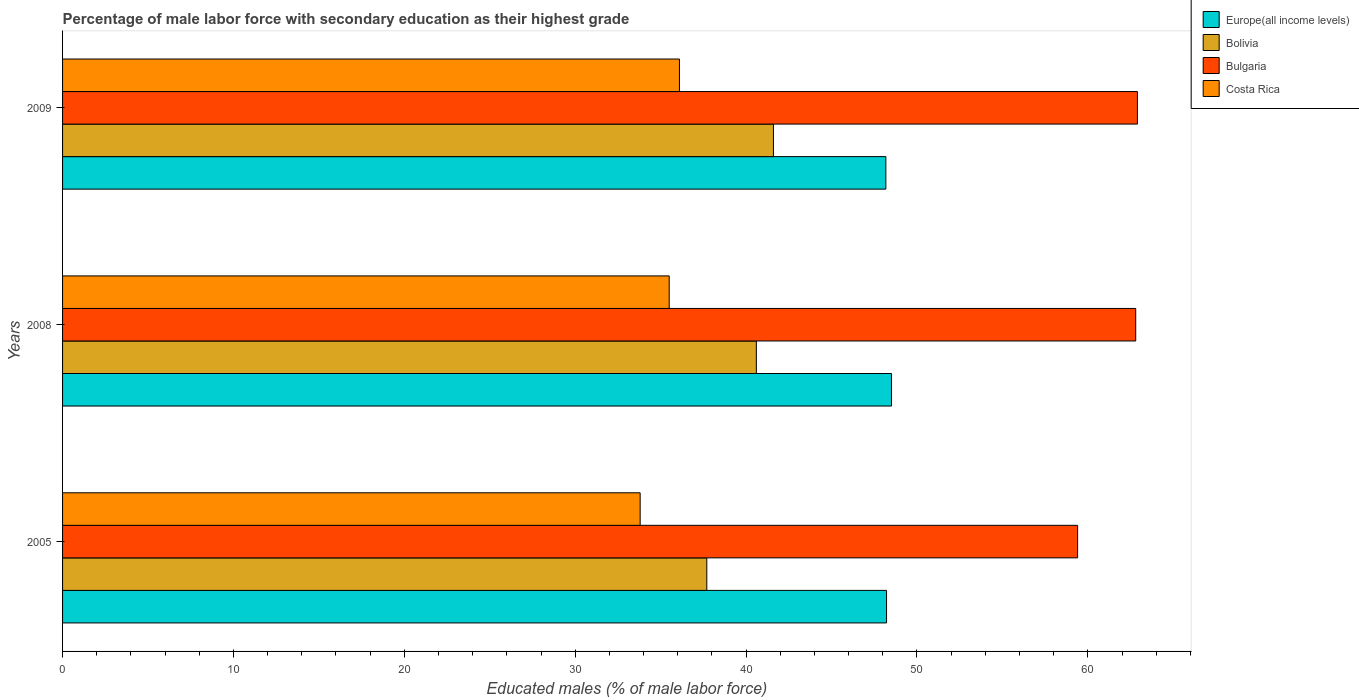How many different coloured bars are there?
Your answer should be very brief. 4. How many groups of bars are there?
Ensure brevity in your answer.  3. Are the number of bars per tick equal to the number of legend labels?
Give a very brief answer. Yes. Are the number of bars on each tick of the Y-axis equal?
Your answer should be very brief. Yes. How many bars are there on the 3rd tick from the bottom?
Your answer should be compact. 4. What is the percentage of male labor force with secondary education in Bolivia in 2008?
Offer a very short reply. 40.6. Across all years, what is the maximum percentage of male labor force with secondary education in Bolivia?
Ensure brevity in your answer.  41.6. Across all years, what is the minimum percentage of male labor force with secondary education in Bolivia?
Give a very brief answer. 37.7. In which year was the percentage of male labor force with secondary education in Costa Rica minimum?
Provide a succinct answer. 2005. What is the total percentage of male labor force with secondary education in Bulgaria in the graph?
Provide a succinct answer. 185.1. What is the difference between the percentage of male labor force with secondary education in Costa Rica in 2005 and that in 2009?
Keep it short and to the point. -2.3. What is the difference between the percentage of male labor force with secondary education in Costa Rica in 2009 and the percentage of male labor force with secondary education in Bolivia in 2008?
Provide a succinct answer. -4.5. What is the average percentage of male labor force with secondary education in Bolivia per year?
Your response must be concise. 39.97. In the year 2008, what is the difference between the percentage of male labor force with secondary education in Bolivia and percentage of male labor force with secondary education in Costa Rica?
Provide a succinct answer. 5.1. What is the ratio of the percentage of male labor force with secondary education in Bolivia in 2005 to that in 2009?
Your answer should be very brief. 0.91. Is the percentage of male labor force with secondary education in Bulgaria in 2005 less than that in 2008?
Give a very brief answer. Yes. Is the difference between the percentage of male labor force with secondary education in Bolivia in 2008 and 2009 greater than the difference between the percentage of male labor force with secondary education in Costa Rica in 2008 and 2009?
Keep it short and to the point. No. What is the difference between the highest and the second highest percentage of male labor force with secondary education in Bulgaria?
Offer a very short reply. 0.1. What is the difference between the highest and the lowest percentage of male labor force with secondary education in Bulgaria?
Provide a succinct answer. 3.5. What does the 4th bar from the top in 2008 represents?
Your response must be concise. Europe(all income levels). Is it the case that in every year, the sum of the percentage of male labor force with secondary education in Europe(all income levels) and percentage of male labor force with secondary education in Bulgaria is greater than the percentage of male labor force with secondary education in Bolivia?
Your answer should be compact. Yes. Are all the bars in the graph horizontal?
Make the answer very short. Yes. How many years are there in the graph?
Provide a succinct answer. 3. What is the difference between two consecutive major ticks on the X-axis?
Your answer should be compact. 10. Does the graph contain any zero values?
Give a very brief answer. No. How many legend labels are there?
Provide a short and direct response. 4. How are the legend labels stacked?
Your response must be concise. Vertical. What is the title of the graph?
Provide a short and direct response. Percentage of male labor force with secondary education as their highest grade. Does "Georgia" appear as one of the legend labels in the graph?
Offer a terse response. No. What is the label or title of the X-axis?
Ensure brevity in your answer.  Educated males (% of male labor force). What is the label or title of the Y-axis?
Your response must be concise. Years. What is the Educated males (% of male labor force) of Europe(all income levels) in 2005?
Provide a short and direct response. 48.22. What is the Educated males (% of male labor force) in Bolivia in 2005?
Give a very brief answer. 37.7. What is the Educated males (% of male labor force) in Bulgaria in 2005?
Provide a succinct answer. 59.4. What is the Educated males (% of male labor force) in Costa Rica in 2005?
Your answer should be very brief. 33.8. What is the Educated males (% of male labor force) of Europe(all income levels) in 2008?
Offer a very short reply. 48.51. What is the Educated males (% of male labor force) in Bolivia in 2008?
Give a very brief answer. 40.6. What is the Educated males (% of male labor force) in Bulgaria in 2008?
Your response must be concise. 62.8. What is the Educated males (% of male labor force) of Costa Rica in 2008?
Your response must be concise. 35.5. What is the Educated males (% of male labor force) of Europe(all income levels) in 2009?
Make the answer very short. 48.18. What is the Educated males (% of male labor force) in Bolivia in 2009?
Your answer should be very brief. 41.6. What is the Educated males (% of male labor force) of Bulgaria in 2009?
Provide a succinct answer. 62.9. What is the Educated males (% of male labor force) in Costa Rica in 2009?
Keep it short and to the point. 36.1. Across all years, what is the maximum Educated males (% of male labor force) of Europe(all income levels)?
Provide a succinct answer. 48.51. Across all years, what is the maximum Educated males (% of male labor force) of Bolivia?
Your response must be concise. 41.6. Across all years, what is the maximum Educated males (% of male labor force) in Bulgaria?
Provide a succinct answer. 62.9. Across all years, what is the maximum Educated males (% of male labor force) in Costa Rica?
Your answer should be compact. 36.1. Across all years, what is the minimum Educated males (% of male labor force) of Europe(all income levels)?
Provide a succinct answer. 48.18. Across all years, what is the minimum Educated males (% of male labor force) of Bolivia?
Your response must be concise. 37.7. Across all years, what is the minimum Educated males (% of male labor force) of Bulgaria?
Provide a succinct answer. 59.4. Across all years, what is the minimum Educated males (% of male labor force) in Costa Rica?
Give a very brief answer. 33.8. What is the total Educated males (% of male labor force) of Europe(all income levels) in the graph?
Ensure brevity in your answer.  144.91. What is the total Educated males (% of male labor force) of Bolivia in the graph?
Offer a very short reply. 119.9. What is the total Educated males (% of male labor force) of Bulgaria in the graph?
Your answer should be compact. 185.1. What is the total Educated males (% of male labor force) of Costa Rica in the graph?
Your answer should be compact. 105.4. What is the difference between the Educated males (% of male labor force) in Europe(all income levels) in 2005 and that in 2008?
Offer a terse response. -0.29. What is the difference between the Educated males (% of male labor force) of Bolivia in 2005 and that in 2008?
Keep it short and to the point. -2.9. What is the difference between the Educated males (% of male labor force) in Costa Rica in 2005 and that in 2008?
Ensure brevity in your answer.  -1.7. What is the difference between the Educated males (% of male labor force) in Europe(all income levels) in 2005 and that in 2009?
Your response must be concise. 0.04. What is the difference between the Educated males (% of male labor force) of Bolivia in 2005 and that in 2009?
Provide a succinct answer. -3.9. What is the difference between the Educated males (% of male labor force) of Bulgaria in 2005 and that in 2009?
Your answer should be very brief. -3.5. What is the difference between the Educated males (% of male labor force) of Costa Rica in 2005 and that in 2009?
Offer a terse response. -2.3. What is the difference between the Educated males (% of male labor force) in Europe(all income levels) in 2008 and that in 2009?
Your response must be concise. 0.33. What is the difference between the Educated males (% of male labor force) of Bulgaria in 2008 and that in 2009?
Offer a terse response. -0.1. What is the difference between the Educated males (% of male labor force) in Europe(all income levels) in 2005 and the Educated males (% of male labor force) in Bolivia in 2008?
Provide a succinct answer. 7.62. What is the difference between the Educated males (% of male labor force) of Europe(all income levels) in 2005 and the Educated males (% of male labor force) of Bulgaria in 2008?
Make the answer very short. -14.58. What is the difference between the Educated males (% of male labor force) in Europe(all income levels) in 2005 and the Educated males (% of male labor force) in Costa Rica in 2008?
Offer a very short reply. 12.72. What is the difference between the Educated males (% of male labor force) of Bolivia in 2005 and the Educated males (% of male labor force) of Bulgaria in 2008?
Your response must be concise. -25.1. What is the difference between the Educated males (% of male labor force) of Bolivia in 2005 and the Educated males (% of male labor force) of Costa Rica in 2008?
Provide a succinct answer. 2.2. What is the difference between the Educated males (% of male labor force) of Bulgaria in 2005 and the Educated males (% of male labor force) of Costa Rica in 2008?
Give a very brief answer. 23.9. What is the difference between the Educated males (% of male labor force) of Europe(all income levels) in 2005 and the Educated males (% of male labor force) of Bolivia in 2009?
Give a very brief answer. 6.62. What is the difference between the Educated males (% of male labor force) of Europe(all income levels) in 2005 and the Educated males (% of male labor force) of Bulgaria in 2009?
Offer a terse response. -14.68. What is the difference between the Educated males (% of male labor force) of Europe(all income levels) in 2005 and the Educated males (% of male labor force) of Costa Rica in 2009?
Your answer should be very brief. 12.12. What is the difference between the Educated males (% of male labor force) in Bolivia in 2005 and the Educated males (% of male labor force) in Bulgaria in 2009?
Offer a terse response. -25.2. What is the difference between the Educated males (% of male labor force) in Bulgaria in 2005 and the Educated males (% of male labor force) in Costa Rica in 2009?
Give a very brief answer. 23.3. What is the difference between the Educated males (% of male labor force) in Europe(all income levels) in 2008 and the Educated males (% of male labor force) in Bolivia in 2009?
Provide a succinct answer. 6.91. What is the difference between the Educated males (% of male labor force) in Europe(all income levels) in 2008 and the Educated males (% of male labor force) in Bulgaria in 2009?
Keep it short and to the point. -14.39. What is the difference between the Educated males (% of male labor force) in Europe(all income levels) in 2008 and the Educated males (% of male labor force) in Costa Rica in 2009?
Ensure brevity in your answer.  12.41. What is the difference between the Educated males (% of male labor force) in Bolivia in 2008 and the Educated males (% of male labor force) in Bulgaria in 2009?
Give a very brief answer. -22.3. What is the difference between the Educated males (% of male labor force) in Bolivia in 2008 and the Educated males (% of male labor force) in Costa Rica in 2009?
Your answer should be very brief. 4.5. What is the difference between the Educated males (% of male labor force) in Bulgaria in 2008 and the Educated males (% of male labor force) in Costa Rica in 2009?
Provide a succinct answer. 26.7. What is the average Educated males (% of male labor force) in Europe(all income levels) per year?
Your response must be concise. 48.3. What is the average Educated males (% of male labor force) in Bolivia per year?
Offer a terse response. 39.97. What is the average Educated males (% of male labor force) of Bulgaria per year?
Ensure brevity in your answer.  61.7. What is the average Educated males (% of male labor force) in Costa Rica per year?
Provide a short and direct response. 35.13. In the year 2005, what is the difference between the Educated males (% of male labor force) of Europe(all income levels) and Educated males (% of male labor force) of Bolivia?
Provide a short and direct response. 10.52. In the year 2005, what is the difference between the Educated males (% of male labor force) in Europe(all income levels) and Educated males (% of male labor force) in Bulgaria?
Offer a terse response. -11.18. In the year 2005, what is the difference between the Educated males (% of male labor force) of Europe(all income levels) and Educated males (% of male labor force) of Costa Rica?
Your response must be concise. 14.42. In the year 2005, what is the difference between the Educated males (% of male labor force) in Bolivia and Educated males (% of male labor force) in Bulgaria?
Offer a very short reply. -21.7. In the year 2005, what is the difference between the Educated males (% of male labor force) of Bulgaria and Educated males (% of male labor force) of Costa Rica?
Your response must be concise. 25.6. In the year 2008, what is the difference between the Educated males (% of male labor force) of Europe(all income levels) and Educated males (% of male labor force) of Bolivia?
Ensure brevity in your answer.  7.91. In the year 2008, what is the difference between the Educated males (% of male labor force) of Europe(all income levels) and Educated males (% of male labor force) of Bulgaria?
Offer a terse response. -14.29. In the year 2008, what is the difference between the Educated males (% of male labor force) of Europe(all income levels) and Educated males (% of male labor force) of Costa Rica?
Offer a very short reply. 13.01. In the year 2008, what is the difference between the Educated males (% of male labor force) in Bolivia and Educated males (% of male labor force) in Bulgaria?
Provide a succinct answer. -22.2. In the year 2008, what is the difference between the Educated males (% of male labor force) of Bolivia and Educated males (% of male labor force) of Costa Rica?
Ensure brevity in your answer.  5.1. In the year 2008, what is the difference between the Educated males (% of male labor force) in Bulgaria and Educated males (% of male labor force) in Costa Rica?
Give a very brief answer. 27.3. In the year 2009, what is the difference between the Educated males (% of male labor force) in Europe(all income levels) and Educated males (% of male labor force) in Bolivia?
Ensure brevity in your answer.  6.58. In the year 2009, what is the difference between the Educated males (% of male labor force) in Europe(all income levels) and Educated males (% of male labor force) in Bulgaria?
Keep it short and to the point. -14.72. In the year 2009, what is the difference between the Educated males (% of male labor force) in Europe(all income levels) and Educated males (% of male labor force) in Costa Rica?
Provide a short and direct response. 12.08. In the year 2009, what is the difference between the Educated males (% of male labor force) of Bolivia and Educated males (% of male labor force) of Bulgaria?
Keep it short and to the point. -21.3. In the year 2009, what is the difference between the Educated males (% of male labor force) in Bolivia and Educated males (% of male labor force) in Costa Rica?
Offer a terse response. 5.5. In the year 2009, what is the difference between the Educated males (% of male labor force) in Bulgaria and Educated males (% of male labor force) in Costa Rica?
Offer a very short reply. 26.8. What is the ratio of the Educated males (% of male labor force) in Bolivia in 2005 to that in 2008?
Ensure brevity in your answer.  0.93. What is the ratio of the Educated males (% of male labor force) in Bulgaria in 2005 to that in 2008?
Provide a succinct answer. 0.95. What is the ratio of the Educated males (% of male labor force) of Costa Rica in 2005 to that in 2008?
Make the answer very short. 0.95. What is the ratio of the Educated males (% of male labor force) of Bolivia in 2005 to that in 2009?
Offer a terse response. 0.91. What is the ratio of the Educated males (% of male labor force) in Costa Rica in 2005 to that in 2009?
Give a very brief answer. 0.94. What is the ratio of the Educated males (% of male labor force) of Europe(all income levels) in 2008 to that in 2009?
Give a very brief answer. 1.01. What is the ratio of the Educated males (% of male labor force) in Bolivia in 2008 to that in 2009?
Offer a terse response. 0.98. What is the ratio of the Educated males (% of male labor force) in Costa Rica in 2008 to that in 2009?
Keep it short and to the point. 0.98. What is the difference between the highest and the second highest Educated males (% of male labor force) of Europe(all income levels)?
Offer a terse response. 0.29. What is the difference between the highest and the second highest Educated males (% of male labor force) in Bulgaria?
Provide a short and direct response. 0.1. What is the difference between the highest and the second highest Educated males (% of male labor force) of Costa Rica?
Ensure brevity in your answer.  0.6. What is the difference between the highest and the lowest Educated males (% of male labor force) of Europe(all income levels)?
Your response must be concise. 0.33. What is the difference between the highest and the lowest Educated males (% of male labor force) of Bolivia?
Ensure brevity in your answer.  3.9. What is the difference between the highest and the lowest Educated males (% of male labor force) of Bulgaria?
Offer a very short reply. 3.5. 